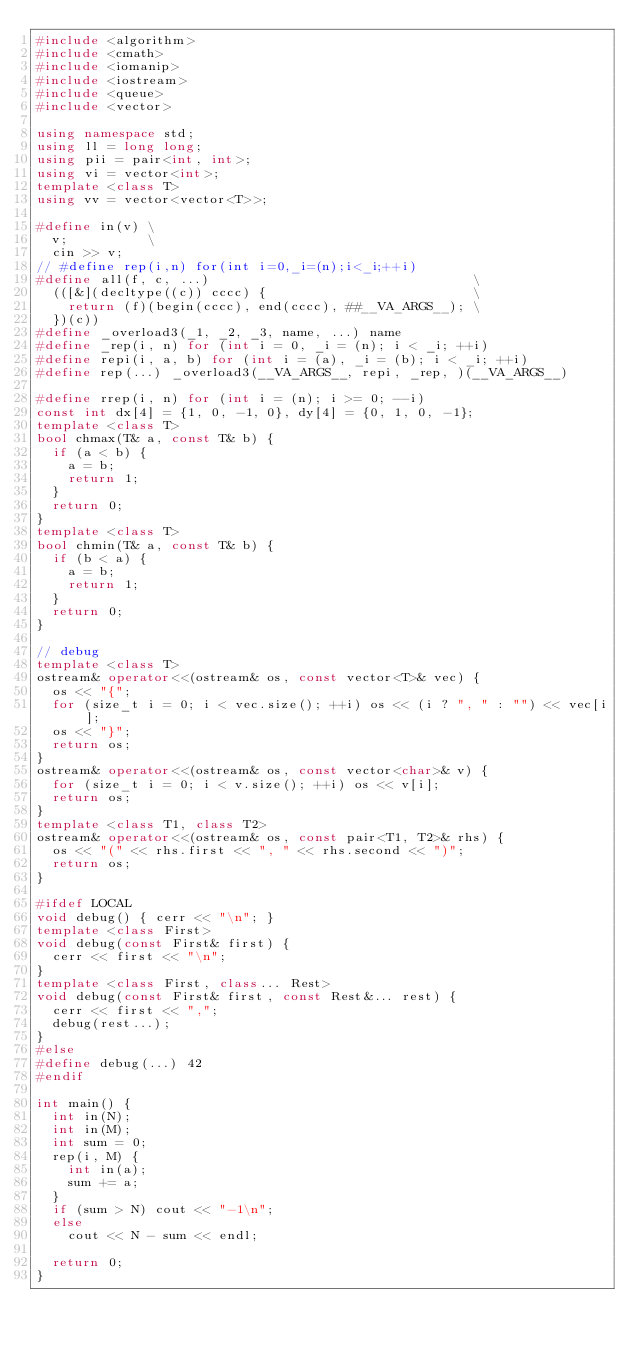<code> <loc_0><loc_0><loc_500><loc_500><_C++_>#include <algorithm>
#include <cmath>
#include <iomanip>
#include <iostream>
#include <queue>
#include <vector>

using namespace std;
using ll = long long;
using pii = pair<int, int>;
using vi = vector<int>;
template <class T>
using vv = vector<vector<T>>;

#define in(v) \
  v;          \
  cin >> v;
// #define rep(i,n) for(int i=0,_i=(n);i<_i;++i)
#define all(f, c, ...)                                 \
  (([&](decltype((c)) cccc) {                          \
    return (f)(begin(cccc), end(cccc), ##__VA_ARGS__); \
  })(c))
#define _overload3(_1, _2, _3, name, ...) name
#define _rep(i, n) for (int i = 0, _i = (n); i < _i; ++i)
#define repi(i, a, b) for (int i = (a), _i = (b); i < _i; ++i)
#define rep(...) _overload3(__VA_ARGS__, repi, _rep, )(__VA_ARGS__)

#define rrep(i, n) for (int i = (n); i >= 0; --i)
const int dx[4] = {1, 0, -1, 0}, dy[4] = {0, 1, 0, -1};
template <class T>
bool chmax(T& a, const T& b) {
  if (a < b) {
    a = b;
    return 1;
  }
  return 0;
}
template <class T>
bool chmin(T& a, const T& b) {
  if (b < a) {
    a = b;
    return 1;
  }
  return 0;
}

// debug
template <class T>
ostream& operator<<(ostream& os, const vector<T>& vec) {
  os << "{";
  for (size_t i = 0; i < vec.size(); ++i) os << (i ? ", " : "") << vec[i];
  os << "}";
  return os;
}
ostream& operator<<(ostream& os, const vector<char>& v) {
  for (size_t i = 0; i < v.size(); ++i) os << v[i];
  return os;
}
template <class T1, class T2>
ostream& operator<<(ostream& os, const pair<T1, T2>& rhs) {
  os << "(" << rhs.first << ", " << rhs.second << ")";
  return os;
}

#ifdef LOCAL
void debug() { cerr << "\n"; }
template <class First>
void debug(const First& first) {
  cerr << first << "\n";
}
template <class First, class... Rest>
void debug(const First& first, const Rest&... rest) {
  cerr << first << ",";
  debug(rest...);
}
#else
#define debug(...) 42
#endif

int main() {
  int in(N);
  int in(M);
  int sum = 0;
  rep(i, M) {
    int in(a);
    sum += a;
  }
  if (sum > N) cout << "-1\n";
  else
    cout << N - sum << endl;

  return 0;
}
</code> 